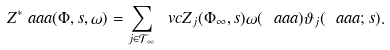<formula> <loc_0><loc_0><loc_500><loc_500>Z ^ { \ast } _ { \ } a a a ( \Phi , s , \omega ) = \sum _ { j \in \mathcal { T } _ { \infty } } \ v c Z _ { j } ( \Phi _ { \infty } , s ) \omega ( \ a a a ) \vartheta _ { j } ( \ a a a ; s ) .</formula> 